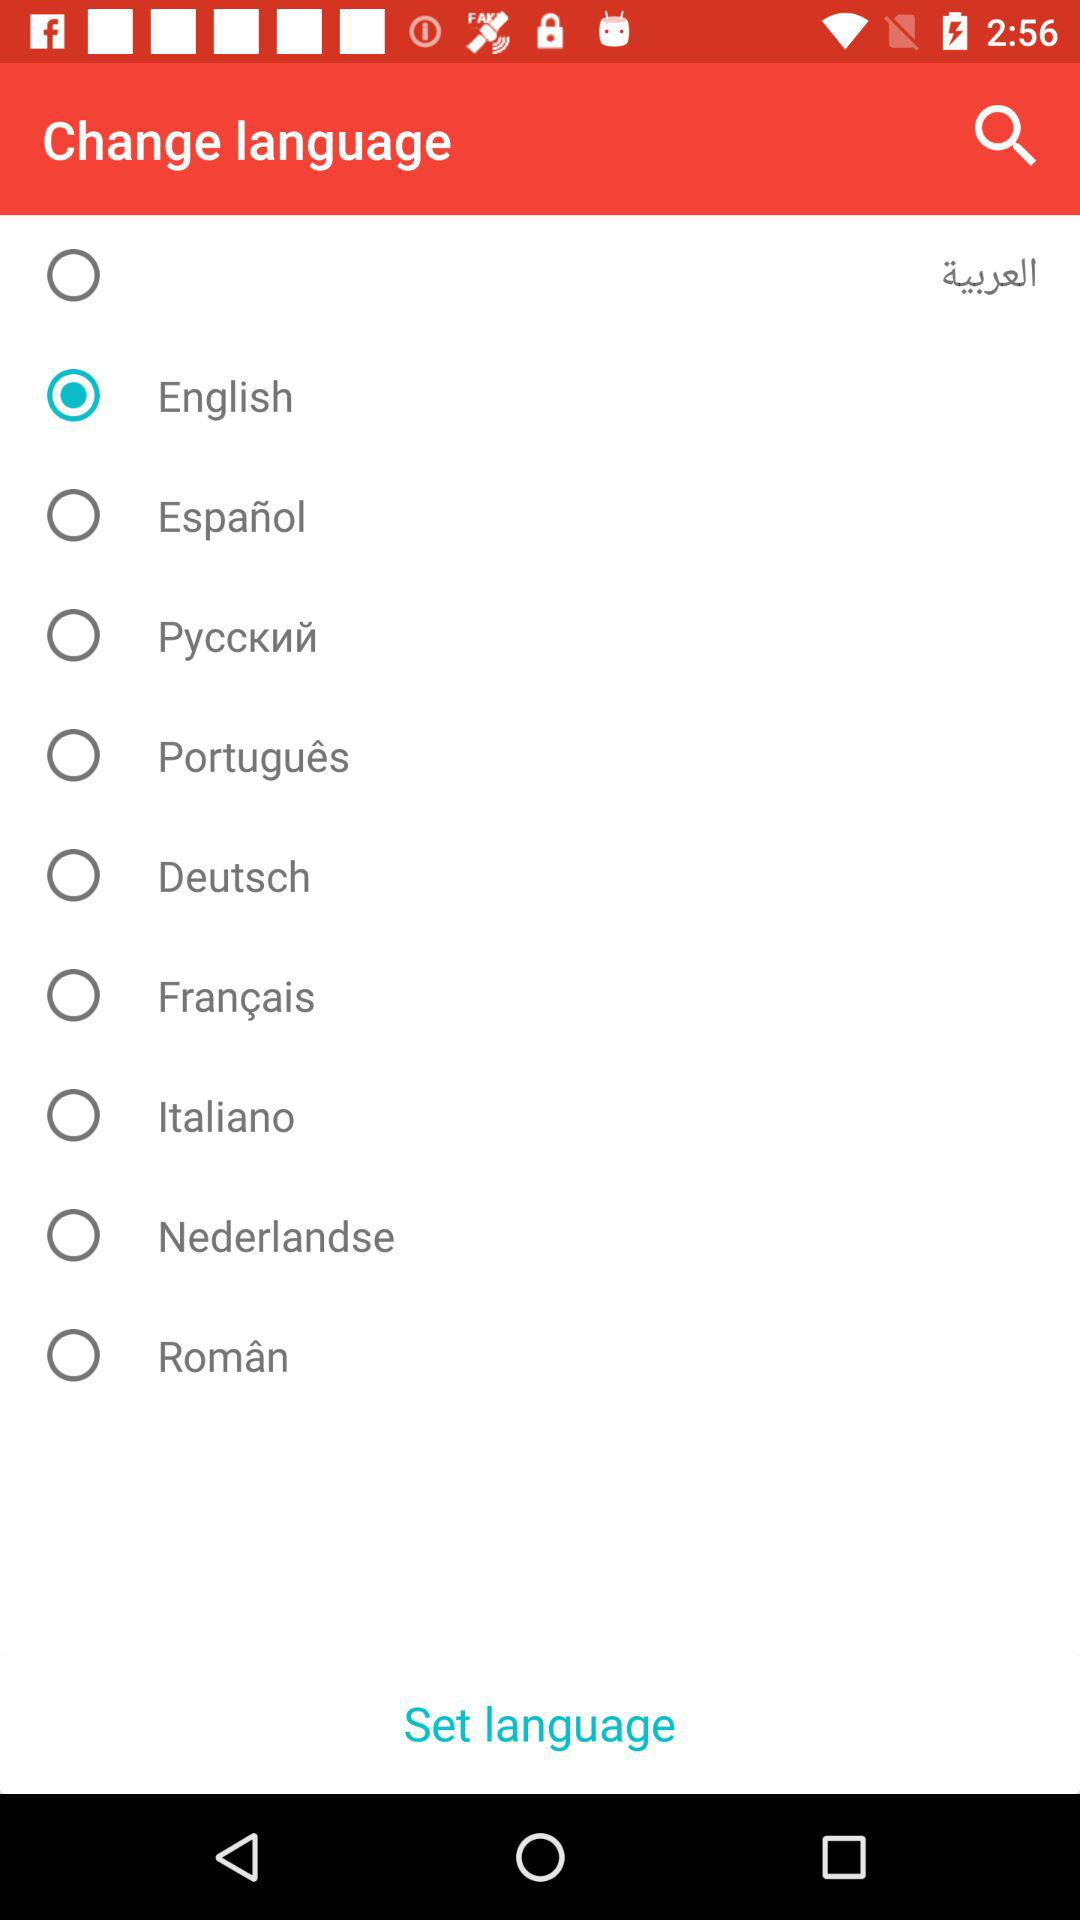How many languages are available to choose from?
Answer the question using a single word or phrase. 10 